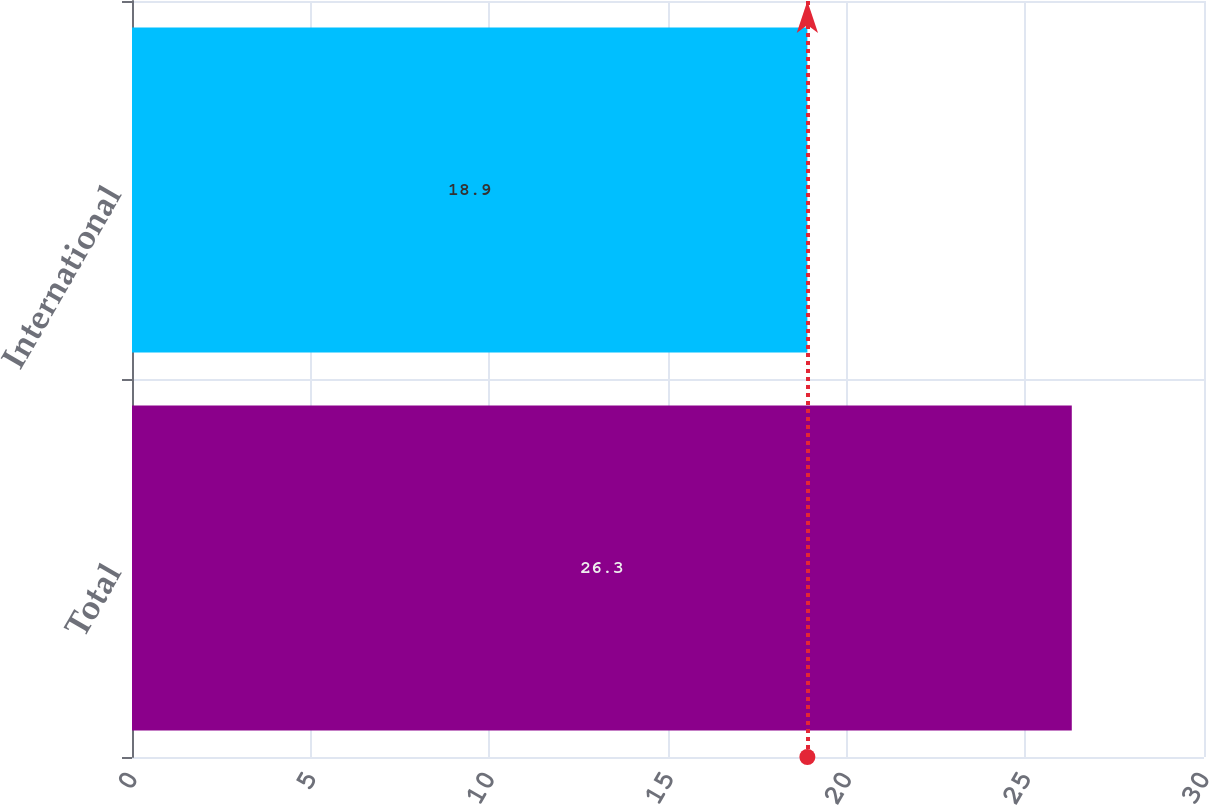Convert chart to OTSL. <chart><loc_0><loc_0><loc_500><loc_500><bar_chart><fcel>Total<fcel>International<nl><fcel>26.3<fcel>18.9<nl></chart> 